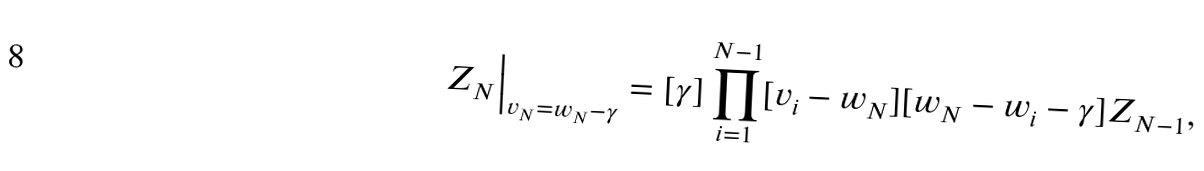Convert formula to latex. <formula><loc_0><loc_0><loc_500><loc_500>Z _ { N } \Big | _ { v _ { N } = w _ { N } - \gamma } & = [ \gamma ] \prod _ { i = 1 } ^ { N - 1 } [ v _ { i } - w _ { N } ] [ w _ { N } - w _ { i } - \gamma ] Z _ { N - 1 } ,</formula> 